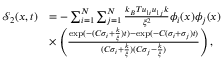Convert formula to latex. <formula><loc_0><loc_0><loc_500><loc_500>\begin{array} { r l } { \mathcal { S } _ { 2 } ( x , t ) } & { = - \sum _ { i = 1 } ^ { N } \sum _ { j = 1 } ^ { N } \frac { k _ { B } T u _ { 1 i } u _ { 1 j } k } { \xi ^ { 2 } } \phi _ { i } ( x ) \phi _ { j } ( x ) } \\ & { \times \left ( \frac { \exp ( - ( C \sigma _ { i } + \frac { k } { \xi } ) t ) - \exp ( - C ( \sigma _ { i } + \sigma _ { j } ) t ) } { ( C \sigma _ { i } + \frac { k } { \xi } ) ( C \sigma _ { j } - \frac { k } { \xi } ) } \right ) , } \end{array}</formula> 